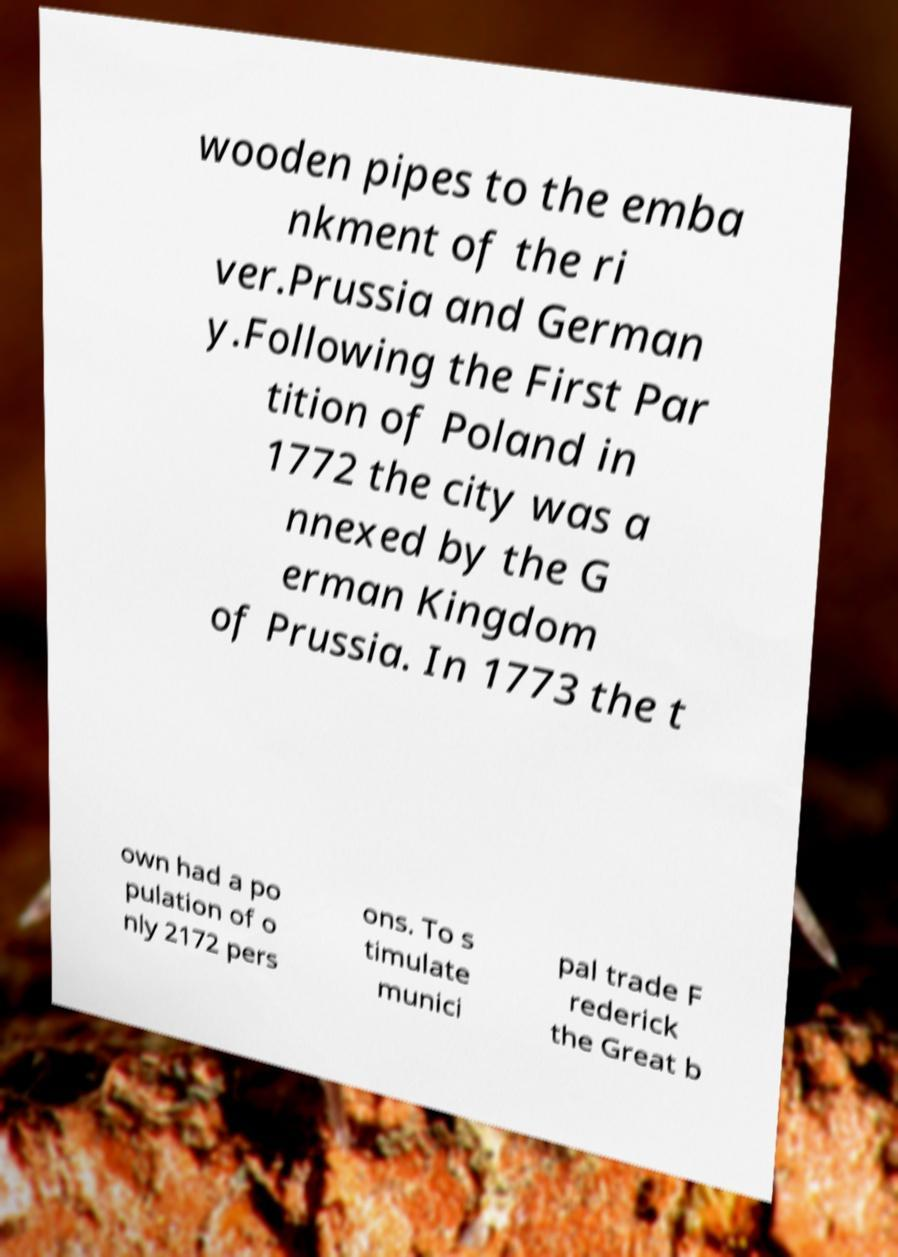Please read and relay the text visible in this image. What does it say? wooden pipes to the emba nkment of the ri ver.Prussia and German y.Following the First Par tition of Poland in 1772 the city was a nnexed by the G erman Kingdom of Prussia. In 1773 the t own had a po pulation of o nly 2172 pers ons. To s timulate munici pal trade F rederick the Great b 